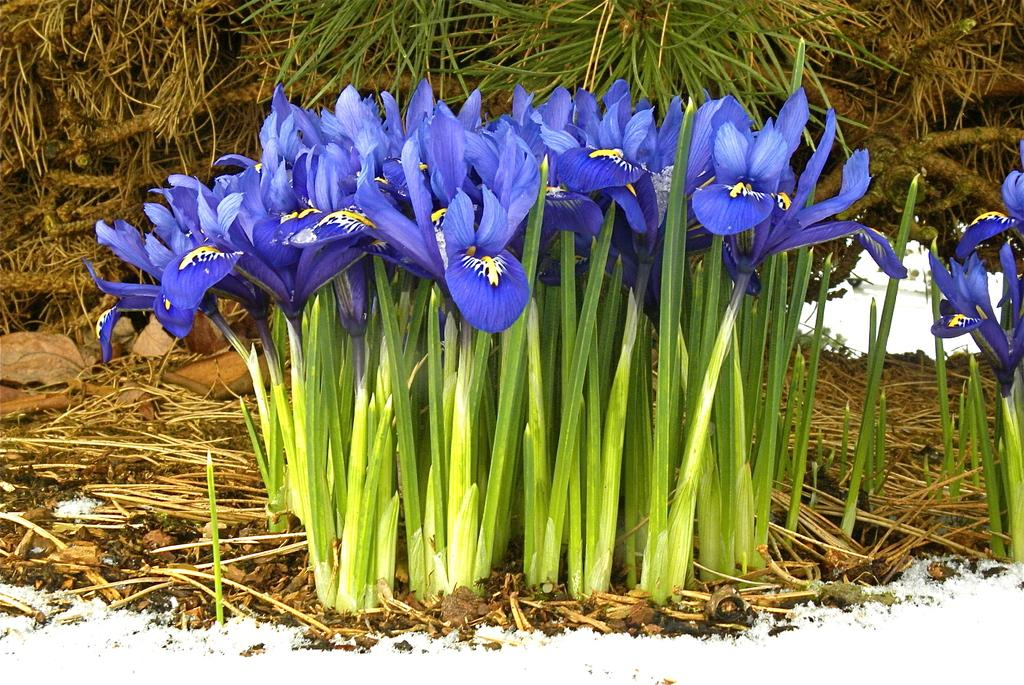What color are the flowers in the image? The flowers in the image are blue. Where are the flowers located in the image? The flowers are in the front of the image. What can be seen in the background of the image? There are leaves in the background of the image. What is the ground made of in the image? Snow is visible at the bottom of the image. What type of thread is being used by the team in the image? There is no team or thread present in the image; it features blue flowers, leaves, and snow. 